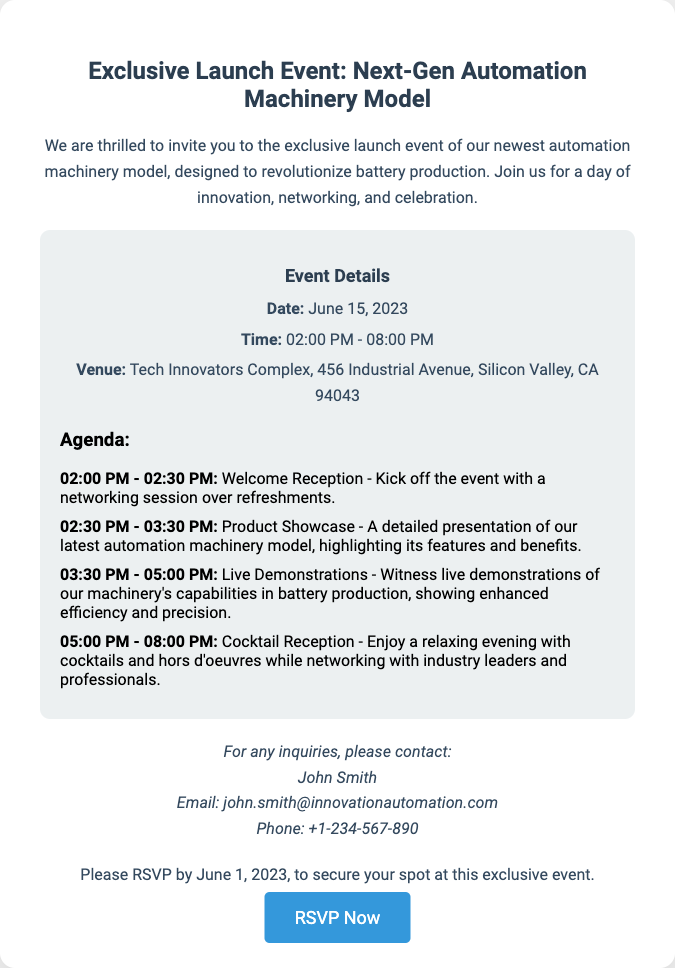what is the date of the event? The date of the event is clearly stated in the document as June 15, 2023.
Answer: June 15, 2023 what time does the event start? The event's starting time is mentioned as 02:00 PM in the document.
Answer: 02:00 PM what is the venue for the event? The venue details provided in the document point to Tech Innovators Complex, located at 456 Industrial Avenue, Silicon Valley, CA 94043.
Answer: Tech Innovators Complex, 456 Industrial Avenue, Silicon Valley, CA 94043 who is the contact person for inquiries? The document specifically mentions John Smith as the contact person for inquiries.
Answer: John Smith what should attendees do to secure their spot? The document instructs attendees to RSVP by June 1, 2023, to secure their spot at the event.
Answer: RSVP by June 1, 2023 how long is the cocktail reception scheduled for? The document states the cocktail reception is from 05:00 PM to 08:00 PM, indicating a duration of 3 hours.
Answer: 3 hours what type of event is being held? The document describes the event as an exclusive launch event for a new automation machinery model.
Answer: Exclusive launch event what can attendees expect during the product showcase? According to the document, attendees can expect a detailed presentation of the automation machinery model during the product showcase.
Answer: Detailed presentation what is the main highlight of the live demonstrations? The live demonstrations will showcase the machinery's capabilities in battery production, emphasizing efficiency and precision.
Answer: Machinery's capabilities in battery production 